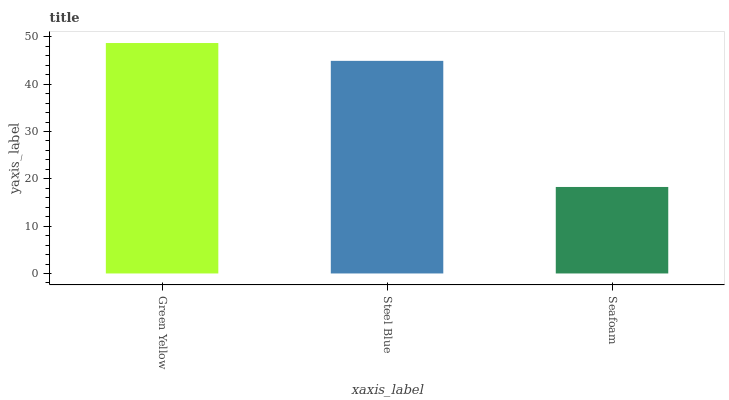Is Seafoam the minimum?
Answer yes or no. Yes. Is Green Yellow the maximum?
Answer yes or no. Yes. Is Steel Blue the minimum?
Answer yes or no. No. Is Steel Blue the maximum?
Answer yes or no. No. Is Green Yellow greater than Steel Blue?
Answer yes or no. Yes. Is Steel Blue less than Green Yellow?
Answer yes or no. Yes. Is Steel Blue greater than Green Yellow?
Answer yes or no. No. Is Green Yellow less than Steel Blue?
Answer yes or no. No. Is Steel Blue the high median?
Answer yes or no. Yes. Is Steel Blue the low median?
Answer yes or no. Yes. Is Seafoam the high median?
Answer yes or no. No. Is Green Yellow the low median?
Answer yes or no. No. 